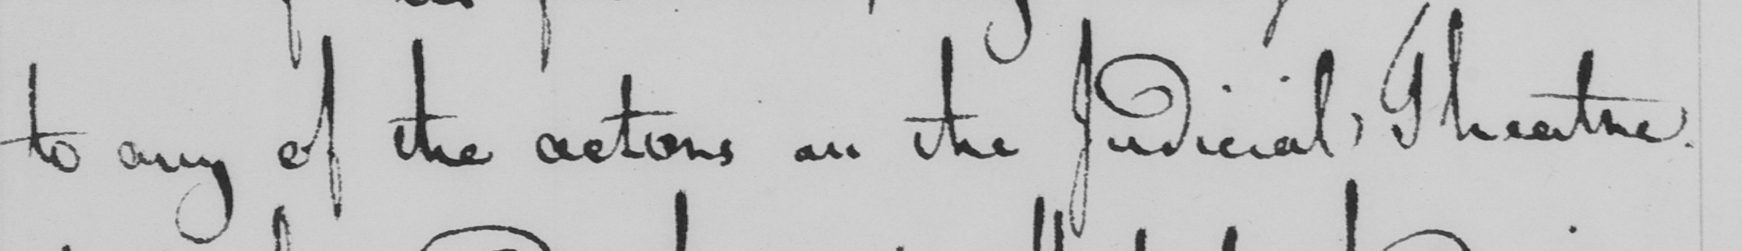Please provide the text content of this handwritten line. to any of the actions on the Judicial Theatre . 